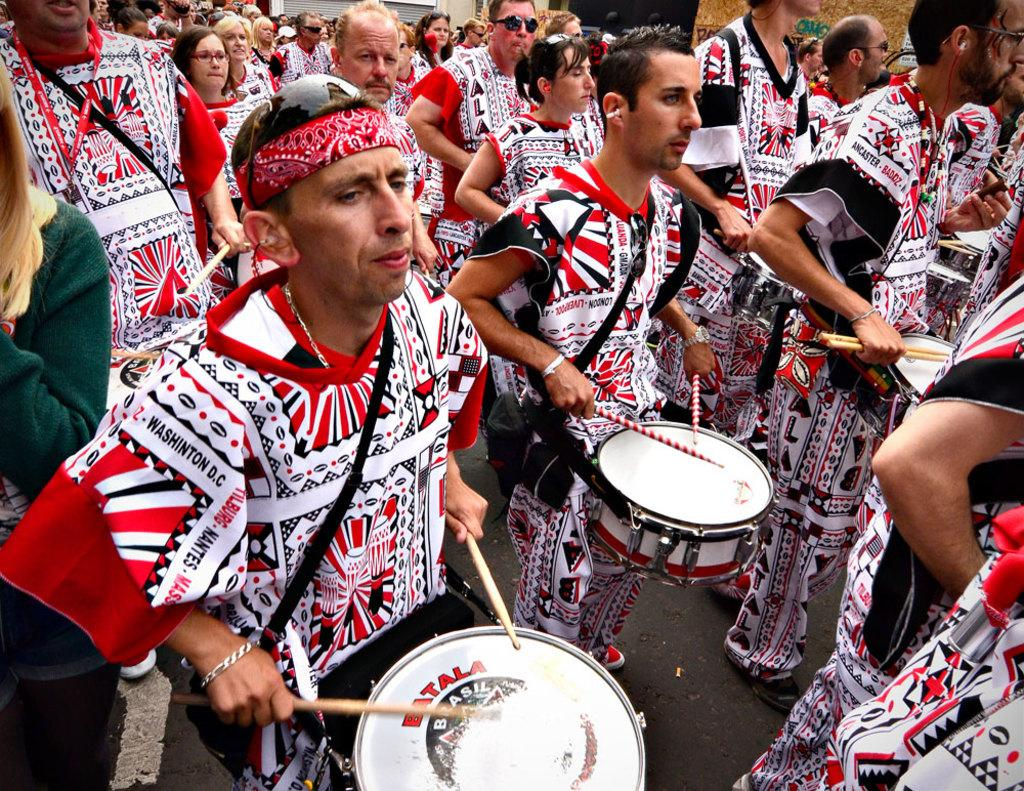What is happening in the image? There is a group of people in the image, and they are standing. What are the people doing in the image? The people are beating drums with drumsticks. What type of pen is being used by the person in the image? There is no pen present in the image; the people are using drumsticks to beat drums. 